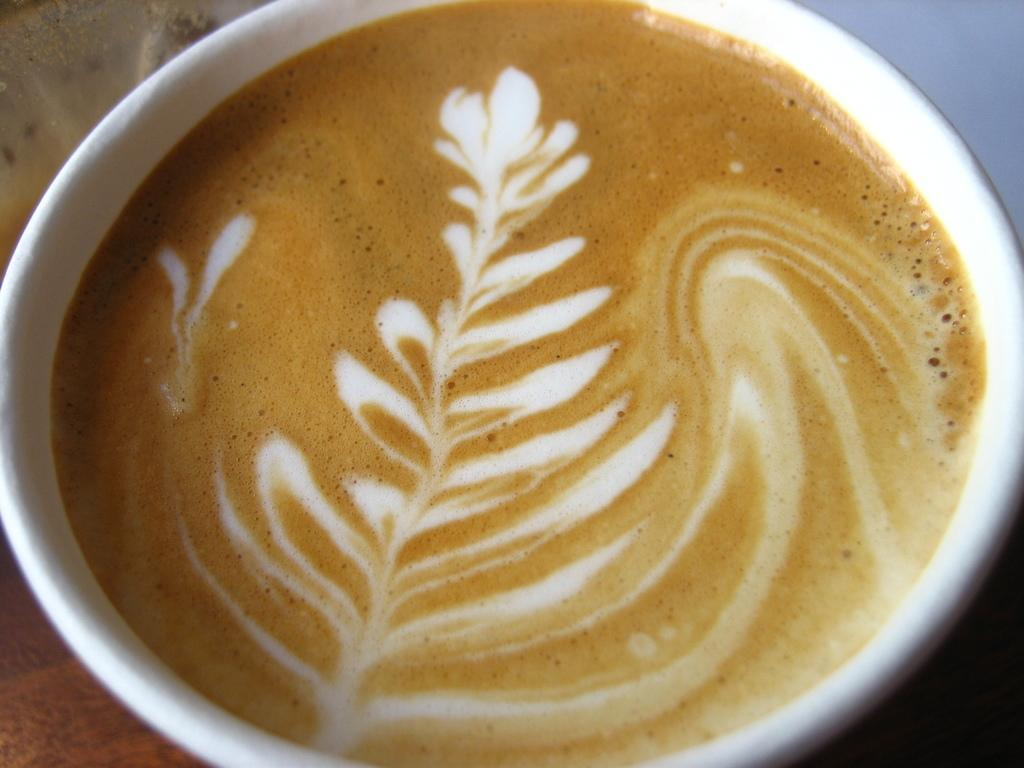What is in the picture? There is a coffee mug in the picture. What is inside the coffee mug? There is coffee in the mug. Can you describe the coffee? The coffee has a design. How many bikes are leaning against the edge of the coffee mug in the image? There are no bikes present in the image, and the coffee mug does not have an edge. 